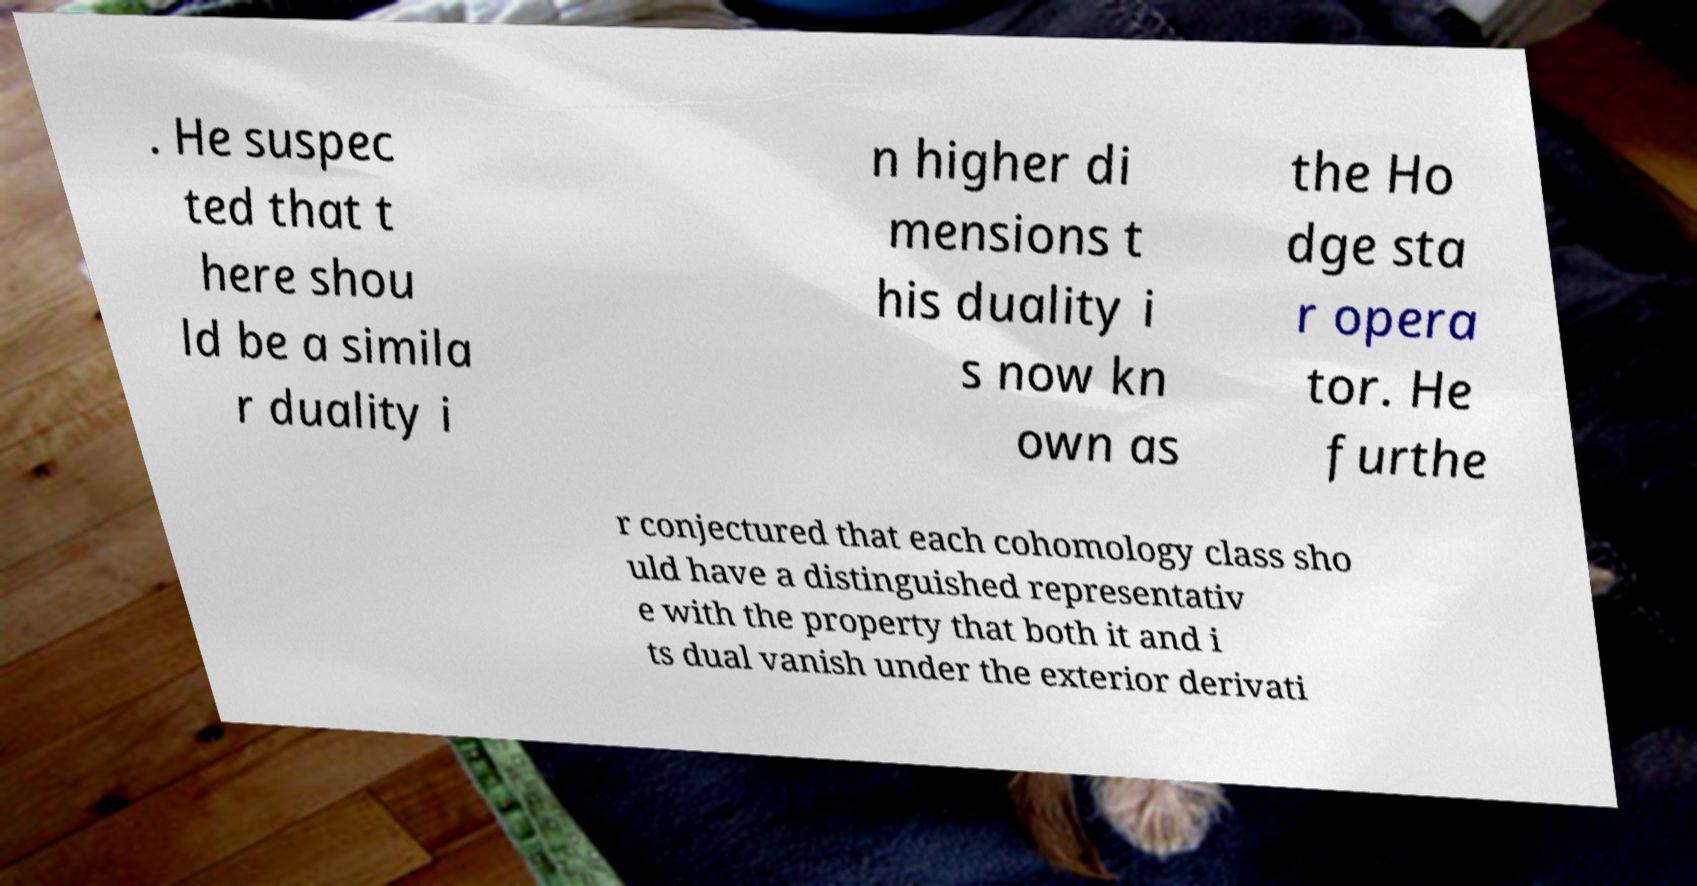For documentation purposes, I need the text within this image transcribed. Could you provide that? . He suspec ted that t here shou ld be a simila r duality i n higher di mensions t his duality i s now kn own as the Ho dge sta r opera tor. He furthe r conjectured that each cohomology class sho uld have a distinguished representativ e with the property that both it and i ts dual vanish under the exterior derivati 